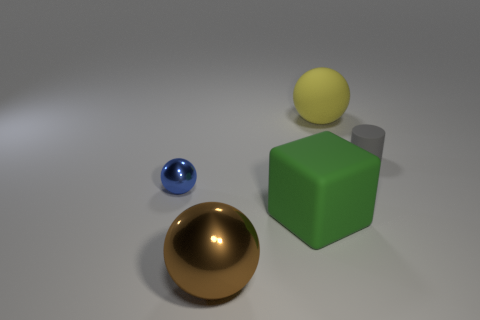The matte thing that is both in front of the large yellow object and left of the gray object is what color?
Ensure brevity in your answer.  Green. What is the shape of the rubber thing that is the same size as the yellow ball?
Offer a very short reply. Cube. Is there another yellow object of the same shape as the tiny shiny thing?
Give a very brief answer. Yes. There is a matte thing in front of the gray matte cylinder; does it have the same size as the small gray thing?
Your answer should be very brief. No. There is a object that is on the right side of the tiny blue sphere and on the left side of the large green rubber block; what is its size?
Your answer should be very brief. Large. What number of other objects are the same material as the brown object?
Your response must be concise. 1. There is a metal object behind the big green thing; what is its size?
Your answer should be compact. Small. How many tiny objects are metallic spheres or blue objects?
Your answer should be very brief. 1. Are there any other things of the same color as the tiny shiny thing?
Offer a terse response. No. Are there any yellow matte objects left of the green matte object?
Offer a very short reply. No. 